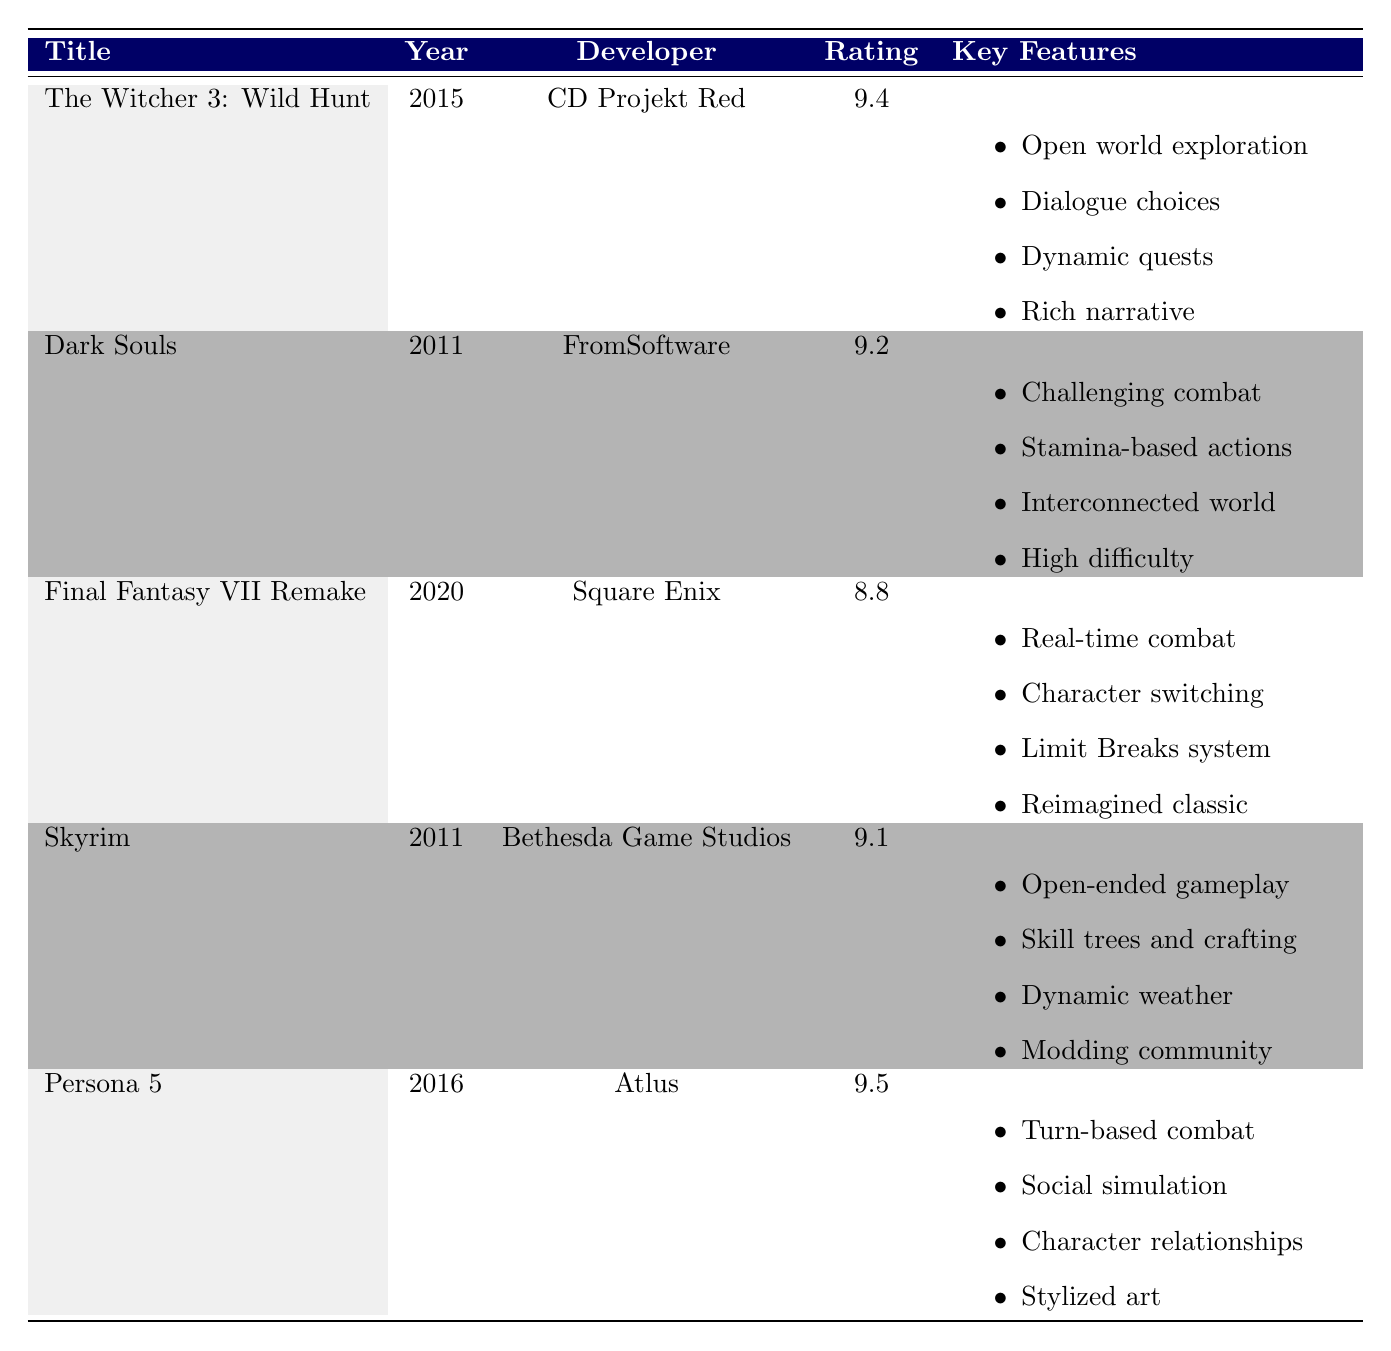What is the user rating of Persona 5? The user rating is specified in the table under the "Rating" column for Persona 5, which shows a score of 9.5.
Answer: 9.5 Which RPG title was released in the year 2020? Looking at the "Year" column, the title corresponding to the year 2020 is "Final Fantasy VII Remake."
Answer: Final Fantasy VII Remake What is the unique feature of Dark Souls? The unique feature for Dark Souls is listed in the last column labeled as "Unique Feature," which states "High difficulty with rewarding gameplay."
Answer: High difficulty with rewarding gameplay Which game has a higher user rating, Skyrim or Final Fantasy VII Remake? The user rating for Skyrim is 9.1, while for Final Fantasy VII Remake, it is 8.8. Since 9.1 is greater than 8.8, Skyrim has the higher rating.
Answer: Skyrim What is the average user rating of all the RPG titles listed in the table? First, we need to sum the user ratings: 9.4 (Witcher 3) + 9.2 (Dark Souls) + 8.8 (Final Fantasy VII Remake) + 9.1 (Skyrim) + 9.5 (Persona 5) = 46. The number of titles is 5. Therefore, the average rating is 46/5 = 9.2.
Answer: 9.2 Is The Witcher 3: Wild Hunt developed by Bethesda Game Studios? The table lists "The Witcher 3: Wild Hunt" under the developer "CD Projekt Red," so the statement is false.
Answer: No Which games feature open world exploration in their gameplay mechanics? Both "The Witcher 3: Wild Hunt" and "Skyrim" have "Open world exploration" listed as part of their gameplay mechanics.
Answer: The Witcher 3: Wild Hunt and Skyrim Which title is noted for having stylized art and storytelling? The unique feature of "Persona 5" includes the description of "Stylized art and storytelling," indicating its distinction in this aspect.
Answer: Persona 5 Are there any RPG titles in the table that were released before 2011? All the titles listed have release years of either 2011 or later. Since there are no titles before 2011, the answer is false.
Answer: No 